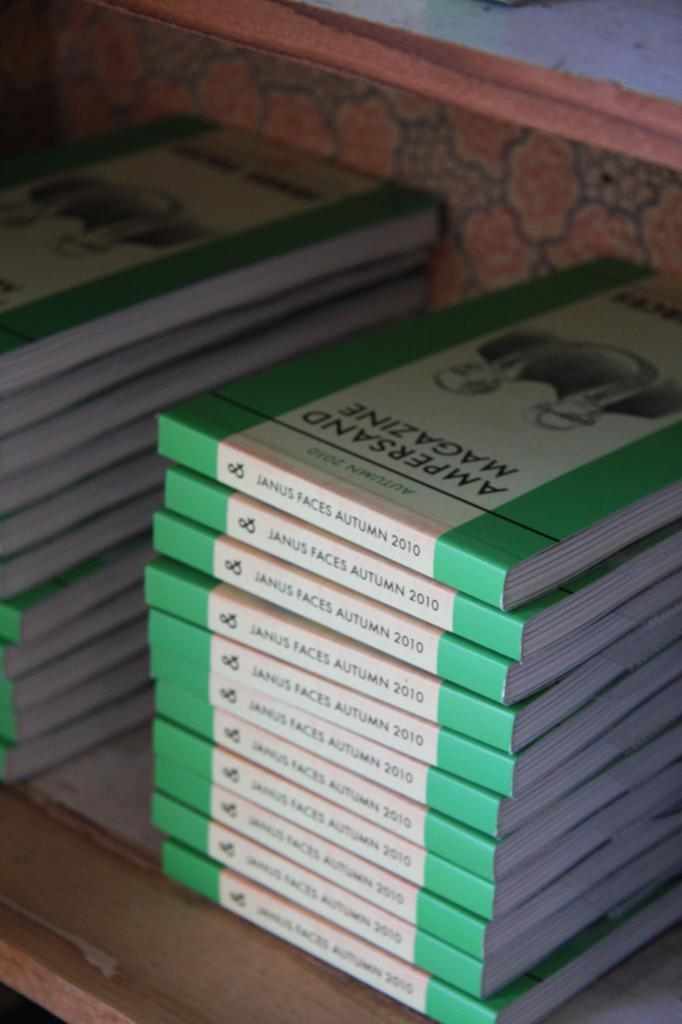Provide a one-sentence caption for the provided image. A stack of Ampersand magazines sit on a shelf. 